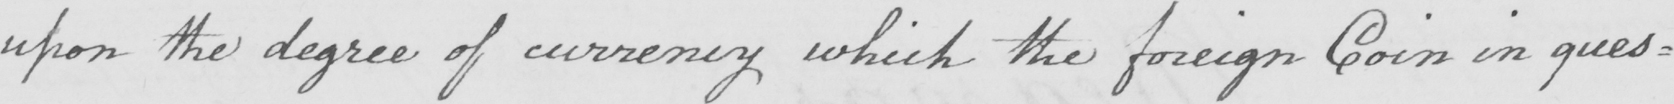What text is written in this handwritten line? upon the degree of currency which the foreign Coin in ques= 